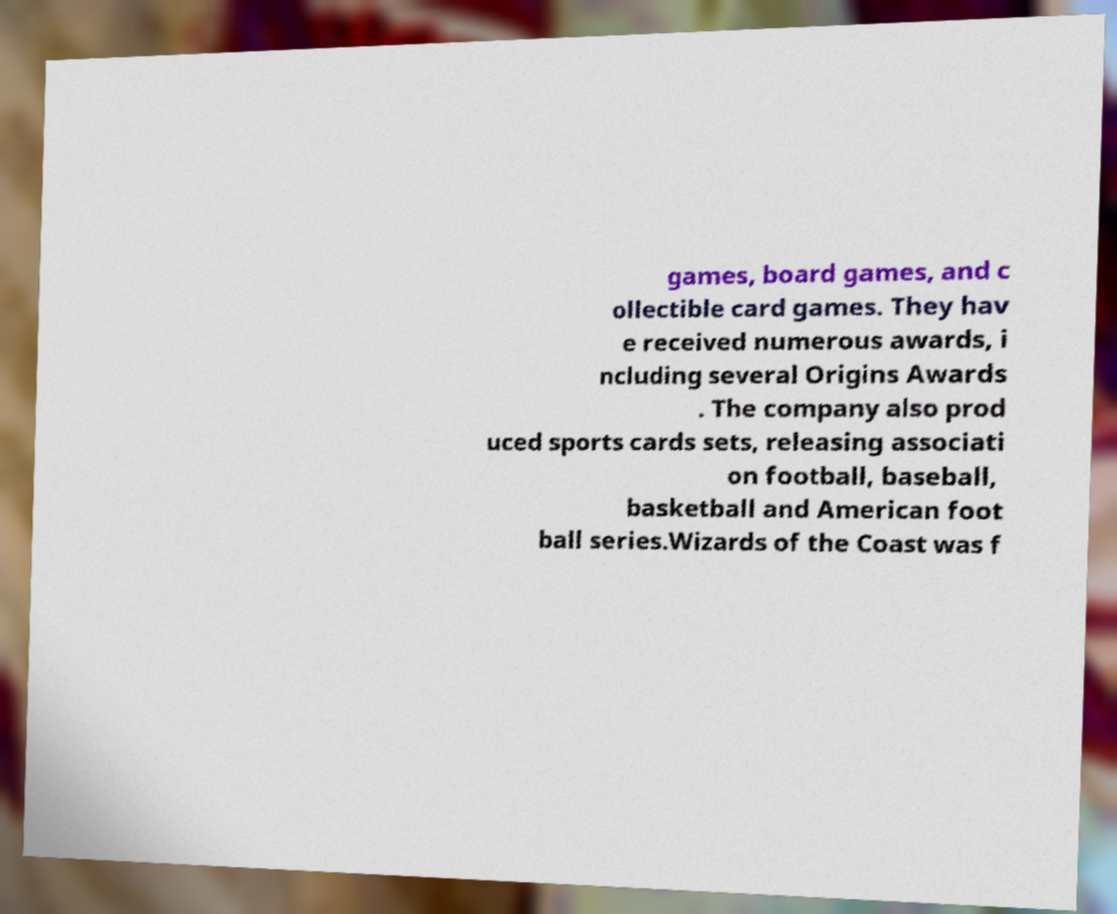There's text embedded in this image that I need extracted. Can you transcribe it verbatim? games, board games, and c ollectible card games. They hav e received numerous awards, i ncluding several Origins Awards . The company also prod uced sports cards sets, releasing associati on football, baseball, basketball and American foot ball series.Wizards of the Coast was f 